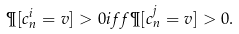<formula> <loc_0><loc_0><loc_500><loc_500>\P [ c ^ { i } _ { n } = v ] > 0 i f f \P [ c ^ { j } _ { n } = v ] > 0 .</formula> 